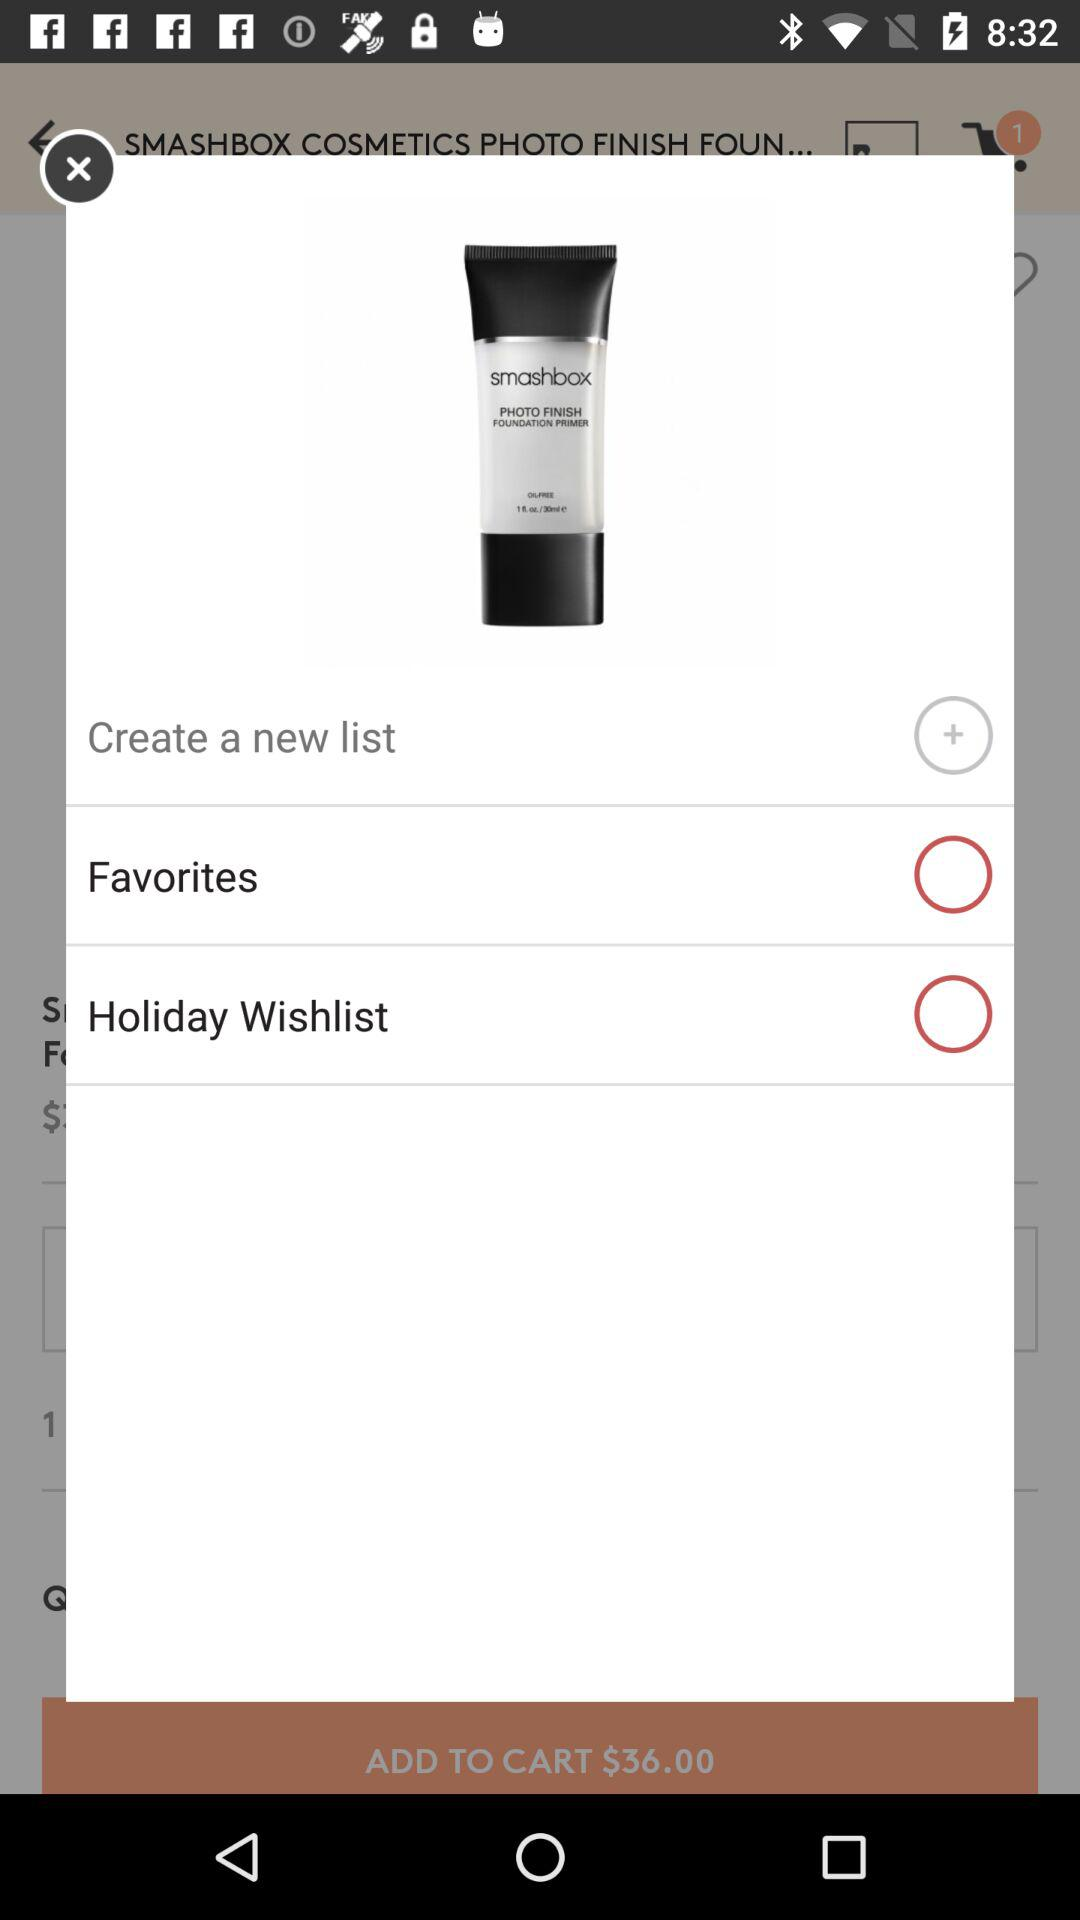What is the status of the Holiday Wishlist? The status is off. 